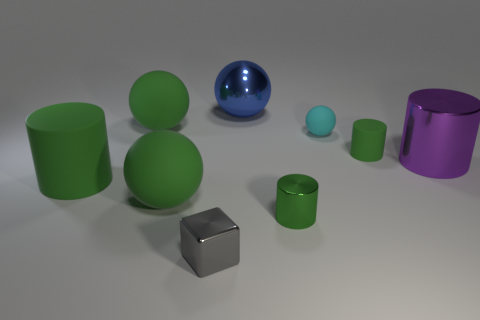Are there any large green objects of the same shape as the large purple metal thing?
Ensure brevity in your answer.  Yes. There is a metal cylinder behind the cylinder on the left side of the tiny gray metallic thing that is on the left side of the purple metal cylinder; what is its size?
Make the answer very short. Large. Are there the same number of large purple metallic cylinders that are in front of the small gray shiny object and balls in front of the cyan sphere?
Offer a very short reply. No. There is a sphere that is the same material as the gray object; what size is it?
Make the answer very short. Large. The big matte cylinder has what color?
Give a very brief answer. Green. How many large rubber balls are the same color as the large matte cylinder?
Your answer should be compact. 2. There is a cyan object that is the same size as the block; what material is it?
Provide a short and direct response. Rubber. Is there a thing that is right of the matte sphere in front of the big purple shiny object?
Make the answer very short. Yes. How many other objects are there of the same color as the tiny block?
Keep it short and to the point. 0. The gray shiny thing is what size?
Keep it short and to the point. Small. 